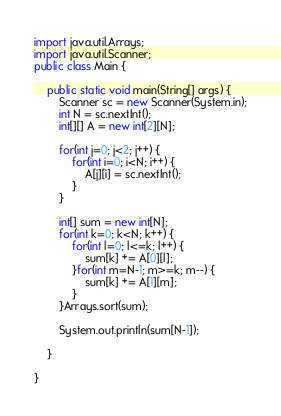<code> <loc_0><loc_0><loc_500><loc_500><_Java_>import java.util.Arrays;
import java.util.Scanner;
public class Main {

	public static void main(String[] args) {
		Scanner sc = new Scanner(System.in);
		int N = sc.nextInt();
		int[][] A = new int[2][N];

		for(int j=0; j<2; j++) {
			for(int i=0; i<N; i++) {
				A[j][i] = sc.nextInt();
			}
		}

		int[] sum = new int[N];
		for(int k=0; k<N; k++) {
			for(int l=0; l<=k; l++) {
				sum[k] += A[0][l];
			}for(int m=N-1; m>=k; m--) {
				sum[k] += A[1][m];
			}
		}Arrays.sort(sum);

		System.out.println(sum[N-1]);

	}

}
</code> 